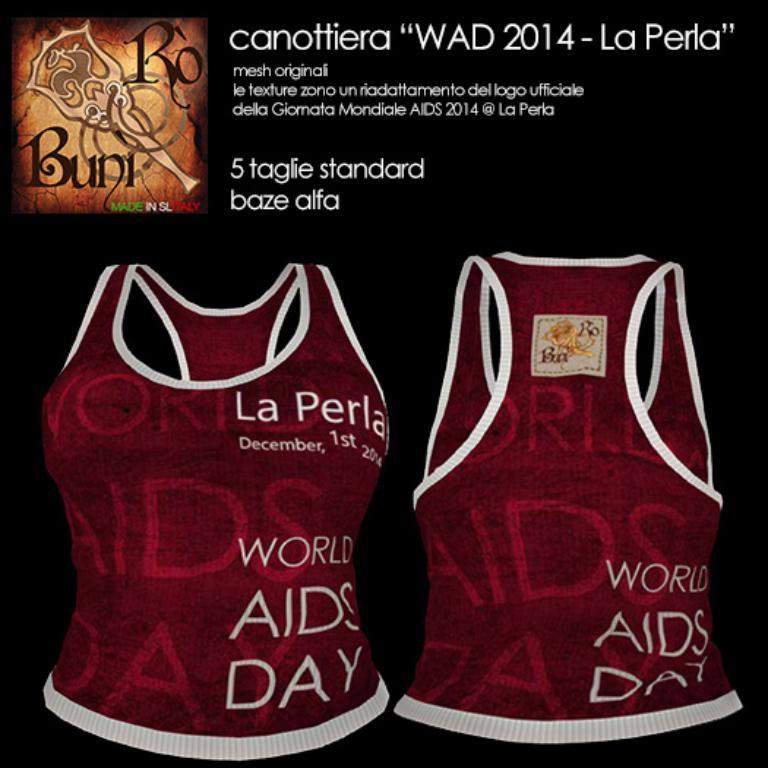What day is the shirt advocating for?
Offer a very short reply. World aids day. 